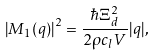Convert formula to latex. <formula><loc_0><loc_0><loc_500><loc_500>\left | M _ { 1 } ( q ) \right | ^ { 2 } = \frac { \hbar { \Xi } _ { d } ^ { 2 } } { 2 \rho c _ { l } V } | q | ,</formula> 